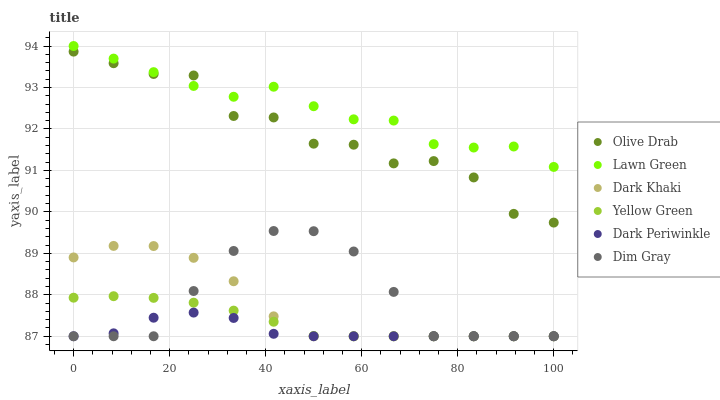Does Dark Periwinkle have the minimum area under the curve?
Answer yes or no. Yes. Does Lawn Green have the maximum area under the curve?
Answer yes or no. Yes. Does Dim Gray have the minimum area under the curve?
Answer yes or no. No. Does Dim Gray have the maximum area under the curve?
Answer yes or no. No. Is Yellow Green the smoothest?
Answer yes or no. Yes. Is Olive Drab the roughest?
Answer yes or no. Yes. Is Dim Gray the smoothest?
Answer yes or no. No. Is Dim Gray the roughest?
Answer yes or no. No. Does Dim Gray have the lowest value?
Answer yes or no. Yes. Does Olive Drab have the lowest value?
Answer yes or no. No. Does Lawn Green have the highest value?
Answer yes or no. Yes. Does Dim Gray have the highest value?
Answer yes or no. No. Is Dark Periwinkle less than Lawn Green?
Answer yes or no. Yes. Is Lawn Green greater than Dark Khaki?
Answer yes or no. Yes. Does Dark Periwinkle intersect Dark Khaki?
Answer yes or no. Yes. Is Dark Periwinkle less than Dark Khaki?
Answer yes or no. No. Is Dark Periwinkle greater than Dark Khaki?
Answer yes or no. No. Does Dark Periwinkle intersect Lawn Green?
Answer yes or no. No. 